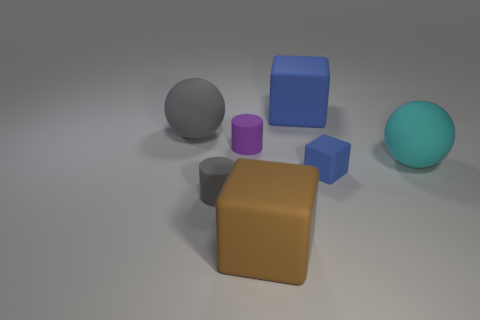Is the shape of the cyan matte thing the same as the purple rubber object?
Offer a very short reply. No. The big cyan thing that is the same material as the tiny purple object is what shape?
Provide a succinct answer. Sphere. There is a ball that is on the left side of the cyan sphere; is it the same size as the matte cylinder that is in front of the cyan rubber sphere?
Provide a succinct answer. No. Are there more gray matte objects behind the small matte cube than rubber blocks that are on the right side of the cyan sphere?
Offer a very short reply. Yes. How many other things are the same color as the small rubber block?
Keep it short and to the point. 1. There is a tiny rubber block; does it have the same color as the large matte sphere that is right of the large gray thing?
Keep it short and to the point. No. There is a rubber block on the left side of the big blue thing; what number of big cyan things are to the left of it?
Provide a succinct answer. 0. Is there anything else that is the same material as the small purple cylinder?
Your answer should be very brief. Yes. What is the material of the brown block that is on the left side of the blue rubber cube that is to the right of the big object behind the large gray rubber thing?
Your answer should be very brief. Rubber. What is the material of the cube that is in front of the purple thing and behind the big brown rubber object?
Make the answer very short. Rubber. 